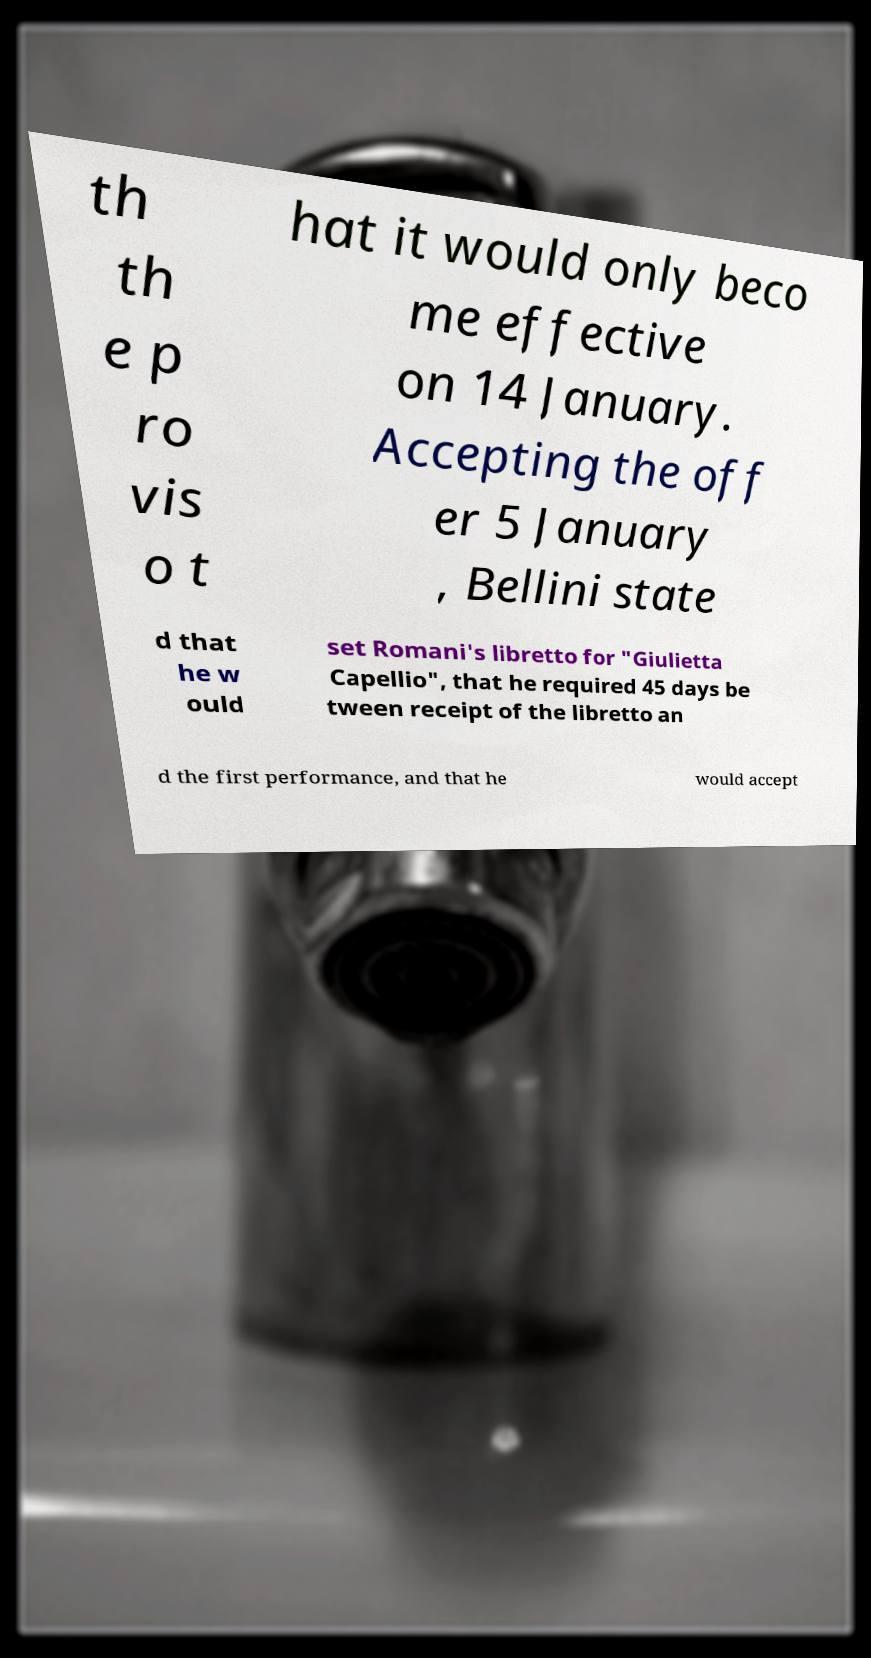I need the written content from this picture converted into text. Can you do that? th th e p ro vis o t hat it would only beco me effective on 14 January. Accepting the off er 5 January , Bellini state d that he w ould set Romani's libretto for "Giulietta Capellio", that he required 45 days be tween receipt of the libretto an d the first performance, and that he would accept 